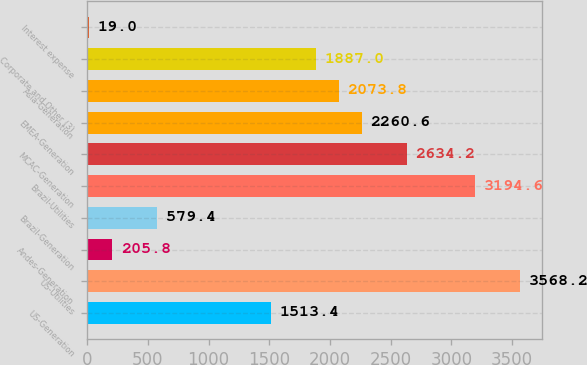Convert chart to OTSL. <chart><loc_0><loc_0><loc_500><loc_500><bar_chart><fcel>US-Generation<fcel>US-Utilities<fcel>Andes-Generation<fcel>Brazil-Generation<fcel>Brazil-Utilities<fcel>MCAC-Generation<fcel>EMEA-Generation<fcel>Asia-Generation<fcel>Corporate and Other (3)<fcel>Interest expense<nl><fcel>1513.4<fcel>3568.2<fcel>205.8<fcel>579.4<fcel>3194.6<fcel>2634.2<fcel>2260.6<fcel>2073.8<fcel>1887<fcel>19<nl></chart> 